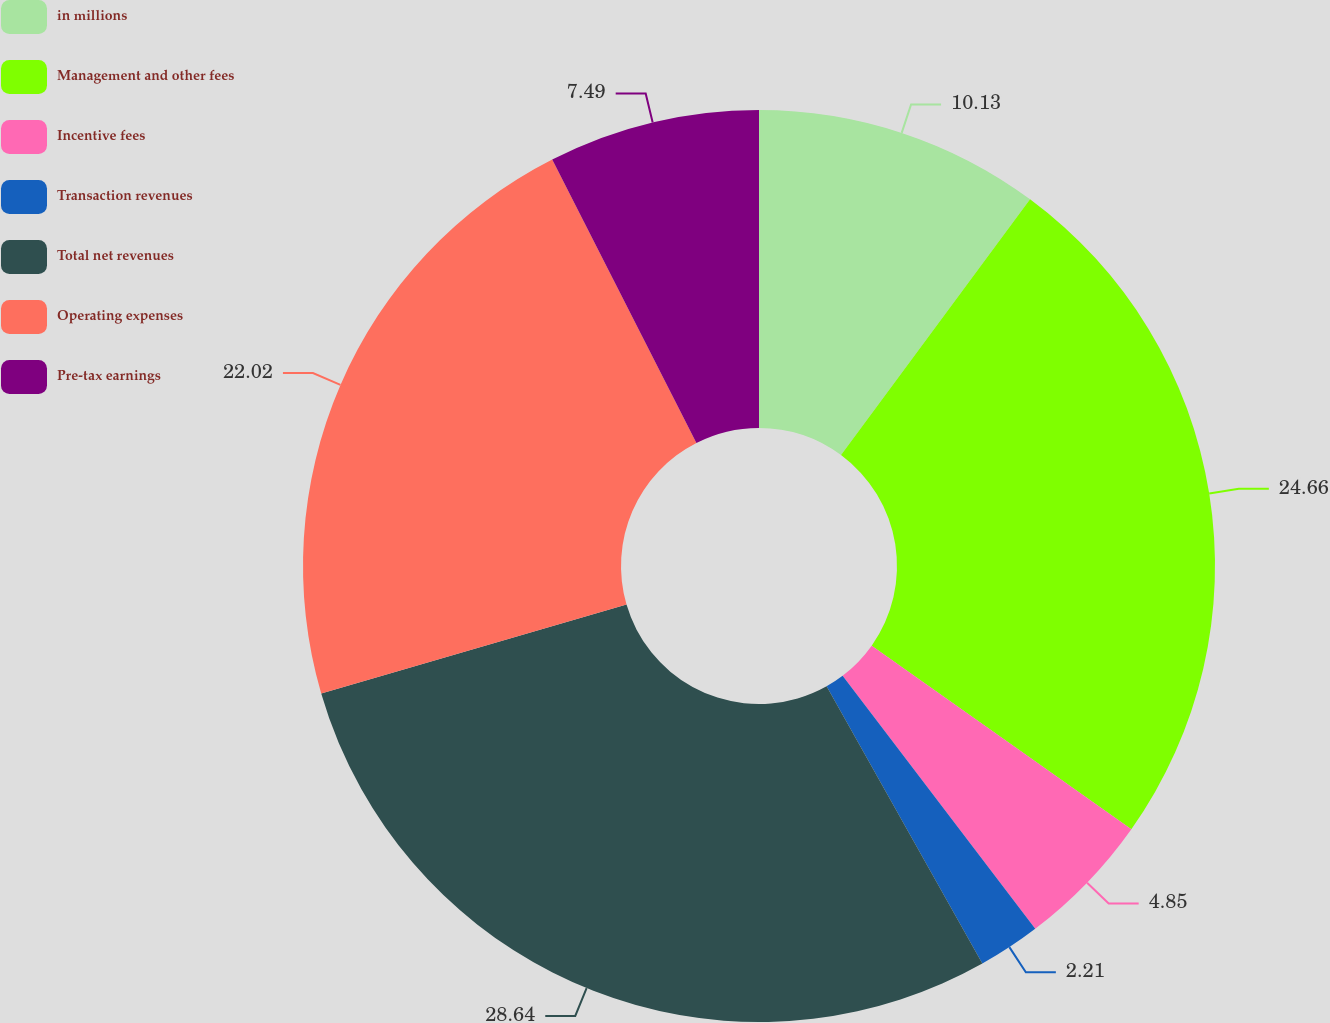Convert chart to OTSL. <chart><loc_0><loc_0><loc_500><loc_500><pie_chart><fcel>in millions<fcel>Management and other fees<fcel>Incentive fees<fcel>Transaction revenues<fcel>Total net revenues<fcel>Operating expenses<fcel>Pre-tax earnings<nl><fcel>10.13%<fcel>24.66%<fcel>4.85%<fcel>2.21%<fcel>28.63%<fcel>22.02%<fcel>7.49%<nl></chart> 